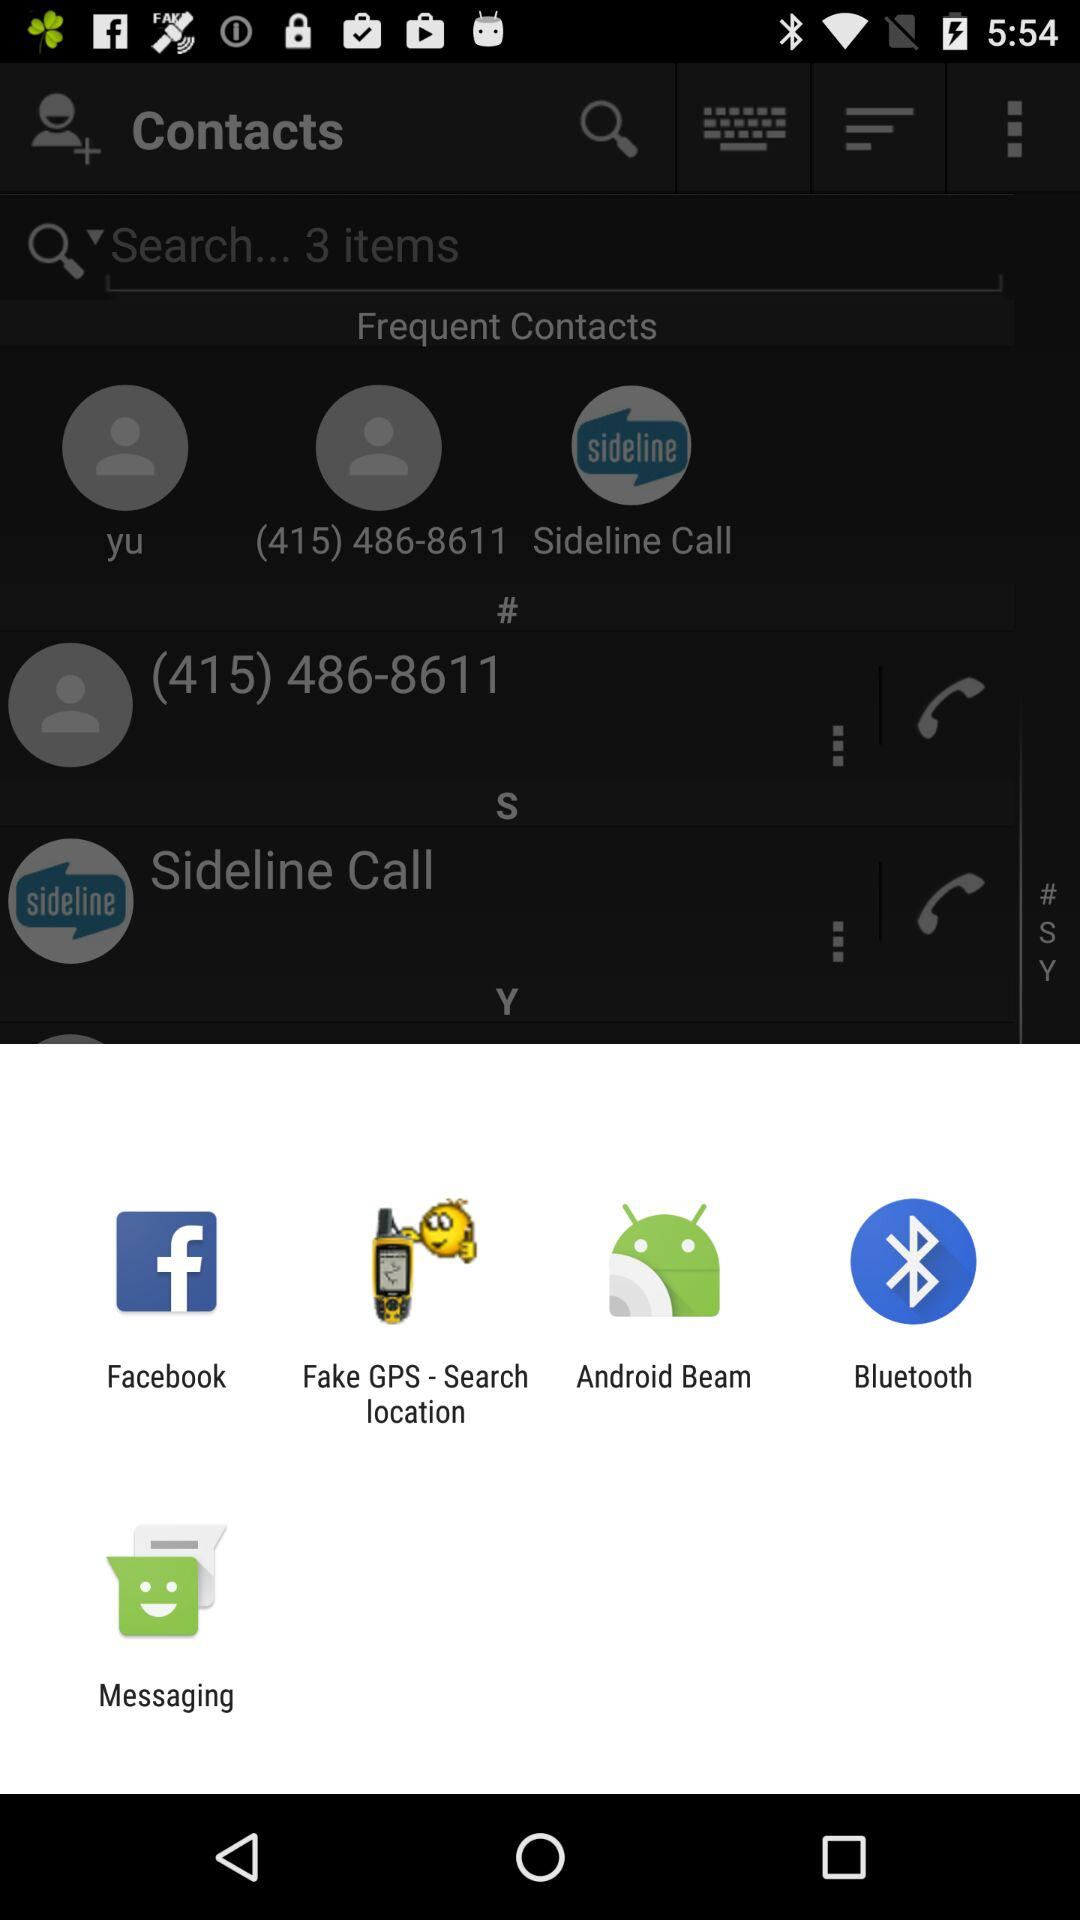What are the displayed applications? The displayed applications are "Sideline", "Facebook", "Fake GPS - Search location", "Android Beam", "Bluetooth" and "Messaging". 